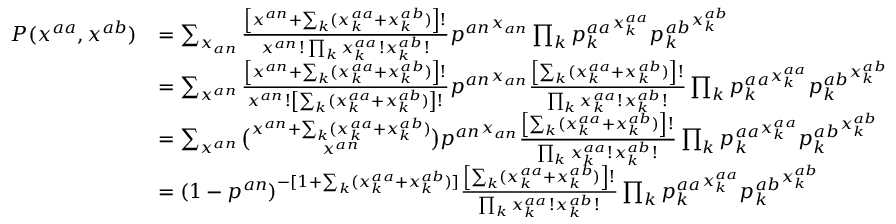<formula> <loc_0><loc_0><loc_500><loc_500>\begin{array} { r l } { P ( x ^ { a a } , x ^ { a b } ) } & { = \sum _ { x _ { a n } } \frac { \left [ x ^ { a n } + \sum _ { k } ( x _ { k } ^ { a a } + x _ { k } ^ { a b } ) \right ] ! } { x ^ { a n } ! \prod _ { k } x _ { k } ^ { a a } ! x _ { k } ^ { a b } ! } { p ^ { a n } } ^ { x _ { a n } } \prod _ { k } { p _ { k } ^ { a a } } ^ { x _ { k } ^ { a a } } { p _ { k } ^ { a b } } ^ { x _ { k } ^ { a b } } } \\ & { = \sum _ { x ^ { a n } } \frac { \left [ x ^ { a n } + \sum _ { k } ( x _ { k } ^ { a a } + x _ { k } ^ { a b } ) \right ] ! } { x ^ { a n } ! \left [ \sum _ { k } ( x _ { k } ^ { a a } + x _ { k } ^ { a b } ) \right ] ! } { p ^ { a n } } ^ { x _ { a n } } \frac { \left [ \sum _ { k } ( x _ { k } ^ { a a } + x _ { k } ^ { a b } ) \right ] ! } { \prod _ { k } x _ { k } ^ { a a } ! x _ { k } ^ { a b } ! } \prod _ { k } { p _ { k } ^ { a a } } ^ { x _ { k } ^ { a a } } { p _ { k } ^ { a b } } ^ { x _ { k } ^ { a b } } } \\ & { = \sum _ { x ^ { a n } } \binom { x ^ { a n } + \sum _ { k } ( x _ { k } ^ { a a } + x _ { k } ^ { a b } ) } { x ^ { a n } } { p ^ { a n } } ^ { x _ { a n } } \frac { \left [ \sum _ { k } ( x _ { k } ^ { a a } + x _ { k } ^ { a b } ) \right ] ! } { \prod _ { k } x _ { k } ^ { a a } ! x _ { k } ^ { a b } ! } \prod _ { k } { p _ { k } ^ { a a } } ^ { x _ { k } ^ { a a } } { p _ { k } ^ { a b } } ^ { x _ { k } ^ { a b } } } \\ & { = ( 1 - p ^ { a n } ) ^ { - [ 1 + \sum _ { k } ( x _ { k } ^ { a a } + x _ { k } ^ { a b } ) ] } \frac { \left [ \sum _ { k } ( x _ { k } ^ { a a } + x _ { k } ^ { a b } ) \right ] ! } { \prod _ { k } x _ { k } ^ { a a } ! x _ { k } ^ { a b } ! } \prod _ { k } { p _ { k } ^ { a a } } ^ { x _ { k } ^ { a a } } { p _ { k } ^ { a b } } ^ { x _ { k } ^ { a b } } } \end{array}</formula> 